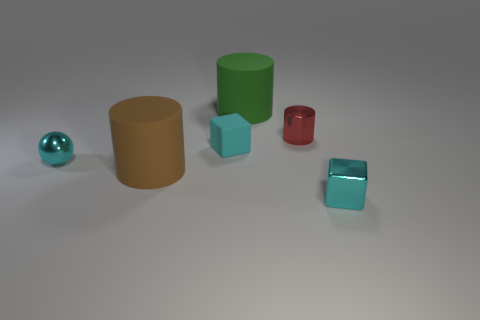Can you tell me the colors of the cylinders from left to right? Certainly! From left to right, the cylinders are tan and green. 